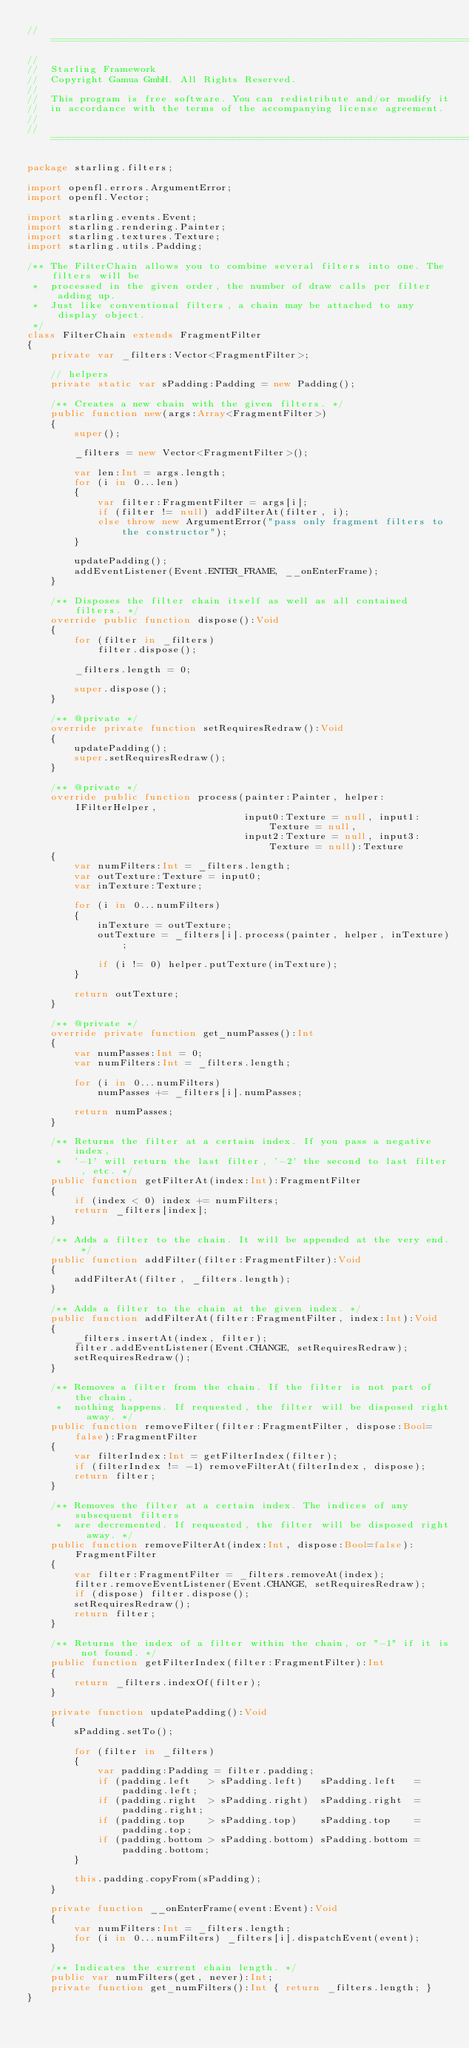Convert code to text. <code><loc_0><loc_0><loc_500><loc_500><_Haxe_>// =================================================================================================
//
//	Starling Framework
//	Copyright Gamua GmbH. All Rights Reserved.
//
//	This program is free software. You can redistribute and/or modify it
//	in accordance with the terms of the accompanying license agreement.
//
// =================================================================================================

package starling.filters;

import openfl.errors.ArgumentError;
import openfl.Vector;

import starling.events.Event;
import starling.rendering.Painter;
import starling.textures.Texture;
import starling.utils.Padding;

/** The FilterChain allows you to combine several filters into one. The filters will be
 *  processed in the given order, the number of draw calls per filter adding up.
 *  Just like conventional filters, a chain may be attached to any display object.
 */
class FilterChain extends FragmentFilter
{
    private var _filters:Vector<FragmentFilter>;

    // helpers
    private static var sPadding:Padding = new Padding();

    /** Creates a new chain with the given filters. */
    public function new(args:Array<FragmentFilter>)
    {
        super();
        
        _filters = new Vector<FragmentFilter>();

        var len:Int = args.length;
        for (i in 0...len)
        {
            var filter:FragmentFilter = args[i];
            if (filter != null) addFilterAt(filter, i);
            else throw new ArgumentError("pass only fragment filters to the constructor");
        }

        updatePadding();
        addEventListener(Event.ENTER_FRAME, __onEnterFrame);
    }

    /** Disposes the filter chain itself as well as all contained filters. */
    override public function dispose():Void
    {
        for (filter in _filters)
            filter.dispose();

        _filters.length = 0;

        super.dispose();
    }

    /** @private */
    override private function setRequiresRedraw():Void
    {
        updatePadding();
        super.setRequiresRedraw();
    }

    /** @private */
    override public function process(painter:Painter, helper:IFilterHelper,
                                     input0:Texture = null, input1:Texture = null,
                                     input2:Texture = null, input3:Texture = null):Texture
    {
        var numFilters:Int = _filters.length;
        var outTexture:Texture = input0;
        var inTexture:Texture;

        for (i in 0...numFilters)
        {
            inTexture = outTexture;
            outTexture = _filters[i].process(painter, helper, inTexture);

            if (i != 0) helper.putTexture(inTexture);
        }

        return outTexture;
    }

    /** @private */
    override private function get_numPasses():Int
    {
        var numPasses:Int = 0;
        var numFilters:Int = _filters.length;

        for (i in 0...numFilters)
            numPasses += _filters[i].numPasses;

        return numPasses;
    }

    /** Returns the filter at a certain index. If you pass a negative index,
     *  '-1' will return the last filter, '-2' the second to last filter, etc. */
    public function getFilterAt(index:Int):FragmentFilter
    {
        if (index < 0) index += numFilters;
        return _filters[index];
    }

    /** Adds a filter to the chain. It will be appended at the very end. */
    public function addFilter(filter:FragmentFilter):Void
    {
        addFilterAt(filter, _filters.length);
    }

    /** Adds a filter to the chain at the given index. */
    public function addFilterAt(filter:FragmentFilter, index:Int):Void
    {
        _filters.insertAt(index, filter);
        filter.addEventListener(Event.CHANGE, setRequiresRedraw);
        setRequiresRedraw();
    }

    /** Removes a filter from the chain. If the filter is not part of the chain,
     *  nothing happens. If requested, the filter will be disposed right away. */
    public function removeFilter(filter:FragmentFilter, dispose:Bool=false):FragmentFilter
    {
        var filterIndex:Int = getFilterIndex(filter);
        if (filterIndex != -1) removeFilterAt(filterIndex, dispose);
        return filter;
    }

    /** Removes the filter at a certain index. The indices of any subsequent filters
     *  are decremented. If requested, the filter will be disposed right away. */
    public function removeFilterAt(index:Int, dispose:Bool=false):FragmentFilter
    {
        var filter:FragmentFilter = _filters.removeAt(index);
        filter.removeEventListener(Event.CHANGE, setRequiresRedraw);
        if (dispose) filter.dispose();
        setRequiresRedraw();
        return filter;
    }

    /** Returns the index of a filter within the chain, or "-1" if it is not found. */
    public function getFilterIndex(filter:FragmentFilter):Int
    {
        return _filters.indexOf(filter);
    }

    private function updatePadding():Void
    {
        sPadding.setTo();

        for (filter in _filters)
        {
            var padding:Padding = filter.padding;
            if (padding.left   > sPadding.left)   sPadding.left   = padding.left;
            if (padding.right  > sPadding.right)  sPadding.right  = padding.right;
            if (padding.top    > sPadding.top)    sPadding.top    = padding.top;
            if (padding.bottom > sPadding.bottom) sPadding.bottom = padding.bottom;
        }

        this.padding.copyFrom(sPadding);
    }

    private function __onEnterFrame(event:Event):Void
    {
        var numFilters:Int = _filters.length;
        for (i in 0...numFilters) _filters[i].dispatchEvent(event);
    }

    /** Indicates the current chain length. */
    public var numFilters(get, never):Int;
    private function get_numFilters():Int { return _filters.length; }
}</code> 